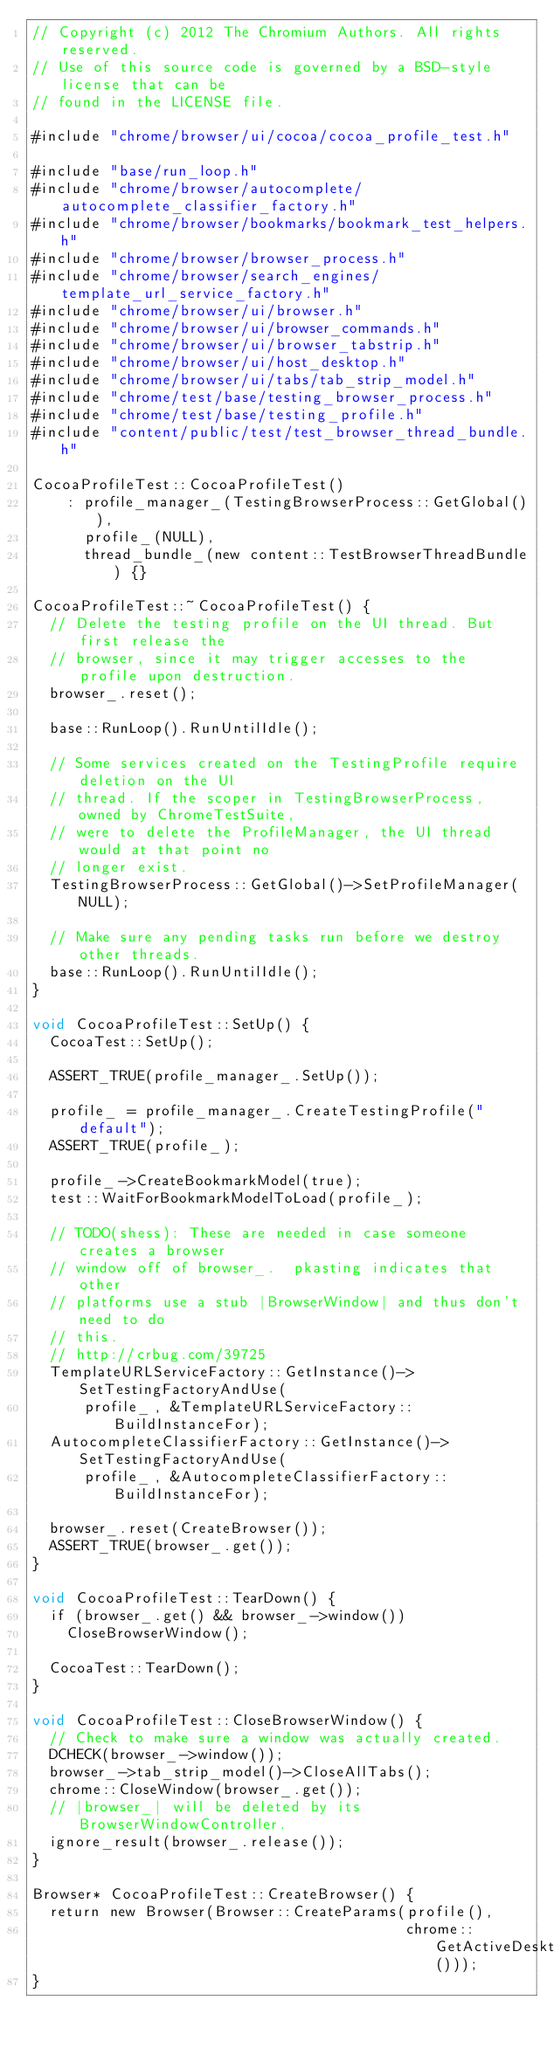<code> <loc_0><loc_0><loc_500><loc_500><_ObjectiveC_>// Copyright (c) 2012 The Chromium Authors. All rights reserved.
// Use of this source code is governed by a BSD-style license that can be
// found in the LICENSE file.

#include "chrome/browser/ui/cocoa/cocoa_profile_test.h"

#include "base/run_loop.h"
#include "chrome/browser/autocomplete/autocomplete_classifier_factory.h"
#include "chrome/browser/bookmarks/bookmark_test_helpers.h"
#include "chrome/browser/browser_process.h"
#include "chrome/browser/search_engines/template_url_service_factory.h"
#include "chrome/browser/ui/browser.h"
#include "chrome/browser/ui/browser_commands.h"
#include "chrome/browser/ui/browser_tabstrip.h"
#include "chrome/browser/ui/host_desktop.h"
#include "chrome/browser/ui/tabs/tab_strip_model.h"
#include "chrome/test/base/testing_browser_process.h"
#include "chrome/test/base/testing_profile.h"
#include "content/public/test/test_browser_thread_bundle.h"

CocoaProfileTest::CocoaProfileTest()
    : profile_manager_(TestingBrowserProcess::GetGlobal()),
      profile_(NULL),
      thread_bundle_(new content::TestBrowserThreadBundle) {}

CocoaProfileTest::~CocoaProfileTest() {
  // Delete the testing profile on the UI thread. But first release the
  // browser, since it may trigger accesses to the profile upon destruction.
  browser_.reset();

  base::RunLoop().RunUntilIdle();

  // Some services created on the TestingProfile require deletion on the UI
  // thread. If the scoper in TestingBrowserProcess, owned by ChromeTestSuite,
  // were to delete the ProfileManager, the UI thread would at that point no
  // longer exist.
  TestingBrowserProcess::GetGlobal()->SetProfileManager(NULL);

  // Make sure any pending tasks run before we destroy other threads.
  base::RunLoop().RunUntilIdle();
}

void CocoaProfileTest::SetUp() {
  CocoaTest::SetUp();

  ASSERT_TRUE(profile_manager_.SetUp());

  profile_ = profile_manager_.CreateTestingProfile("default");
  ASSERT_TRUE(profile_);

  profile_->CreateBookmarkModel(true);
  test::WaitForBookmarkModelToLoad(profile_);

  // TODO(shess): These are needed in case someone creates a browser
  // window off of browser_.  pkasting indicates that other
  // platforms use a stub |BrowserWindow| and thus don't need to do
  // this.
  // http://crbug.com/39725
  TemplateURLServiceFactory::GetInstance()->SetTestingFactoryAndUse(
      profile_, &TemplateURLServiceFactory::BuildInstanceFor);
  AutocompleteClassifierFactory::GetInstance()->SetTestingFactoryAndUse(
      profile_, &AutocompleteClassifierFactory::BuildInstanceFor);

  browser_.reset(CreateBrowser());
  ASSERT_TRUE(browser_.get());
}

void CocoaProfileTest::TearDown() {
  if (browser_.get() && browser_->window())
    CloseBrowserWindow();

  CocoaTest::TearDown();
}

void CocoaProfileTest::CloseBrowserWindow() {
  // Check to make sure a window was actually created.
  DCHECK(browser_->window());
  browser_->tab_strip_model()->CloseAllTabs();
  chrome::CloseWindow(browser_.get());
  // |browser_| will be deleted by its BrowserWindowController.
  ignore_result(browser_.release());
}

Browser* CocoaProfileTest::CreateBrowser() {
  return new Browser(Browser::CreateParams(profile(),
                                           chrome::GetActiveDesktop()));
}
</code> 